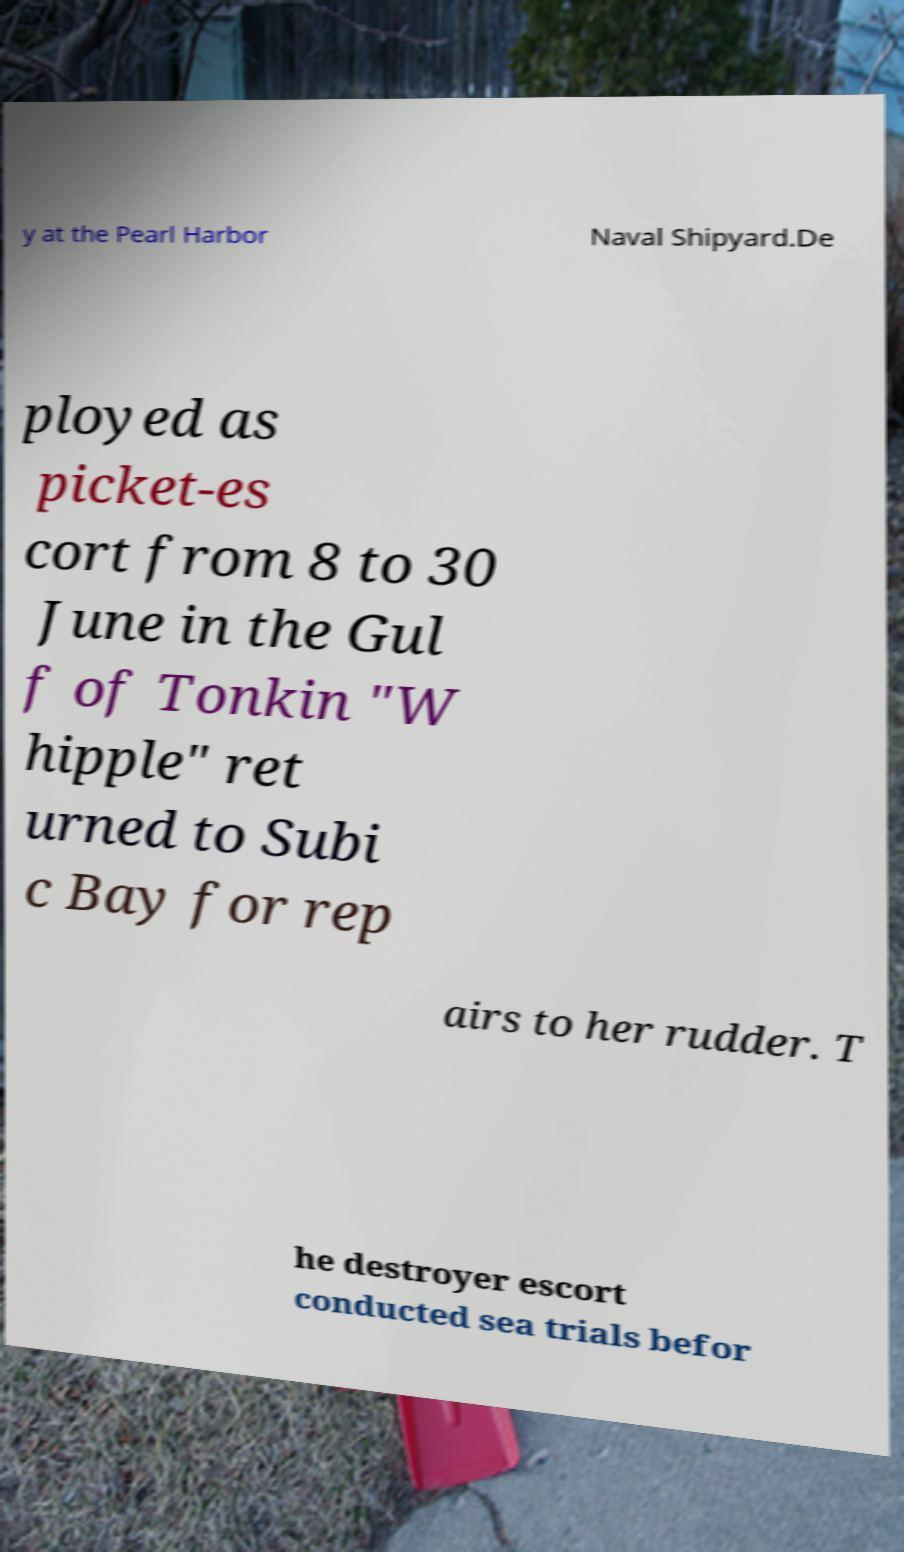Could you extract and type out the text from this image? y at the Pearl Harbor Naval Shipyard.De ployed as picket-es cort from 8 to 30 June in the Gul f of Tonkin "W hipple" ret urned to Subi c Bay for rep airs to her rudder. T he destroyer escort conducted sea trials befor 